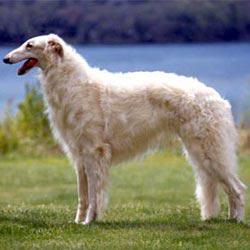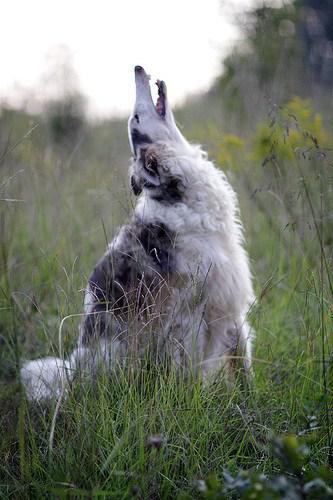The first image is the image on the left, the second image is the image on the right. Considering the images on both sides, is "One of the pictures contains two dogs." valid? Answer yes or no. No. The first image is the image on the left, the second image is the image on the right. For the images displayed, is the sentence "An image shows exactly two hounds, which face one another." factually correct? Answer yes or no. No. 